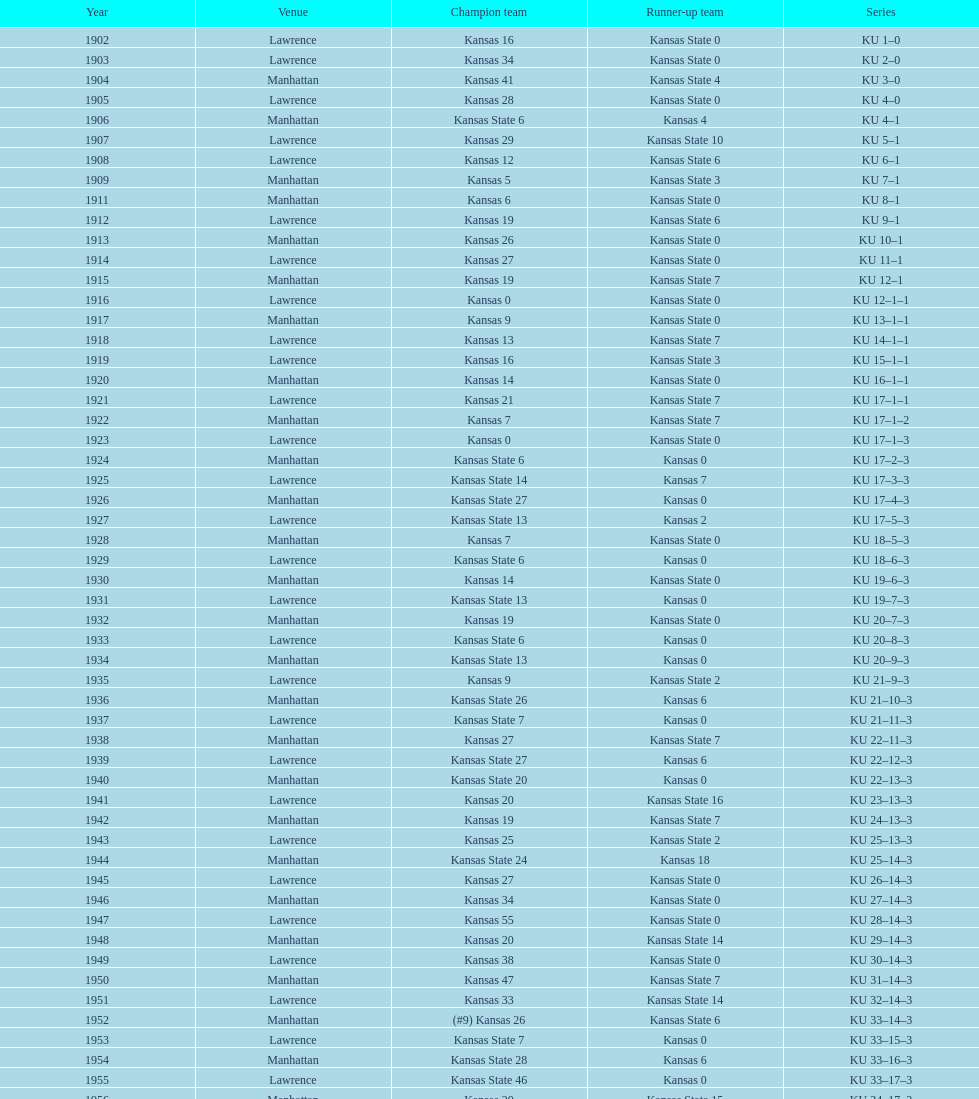How many times did kansas state not score at all against kansas from 1902-1968? 23. 